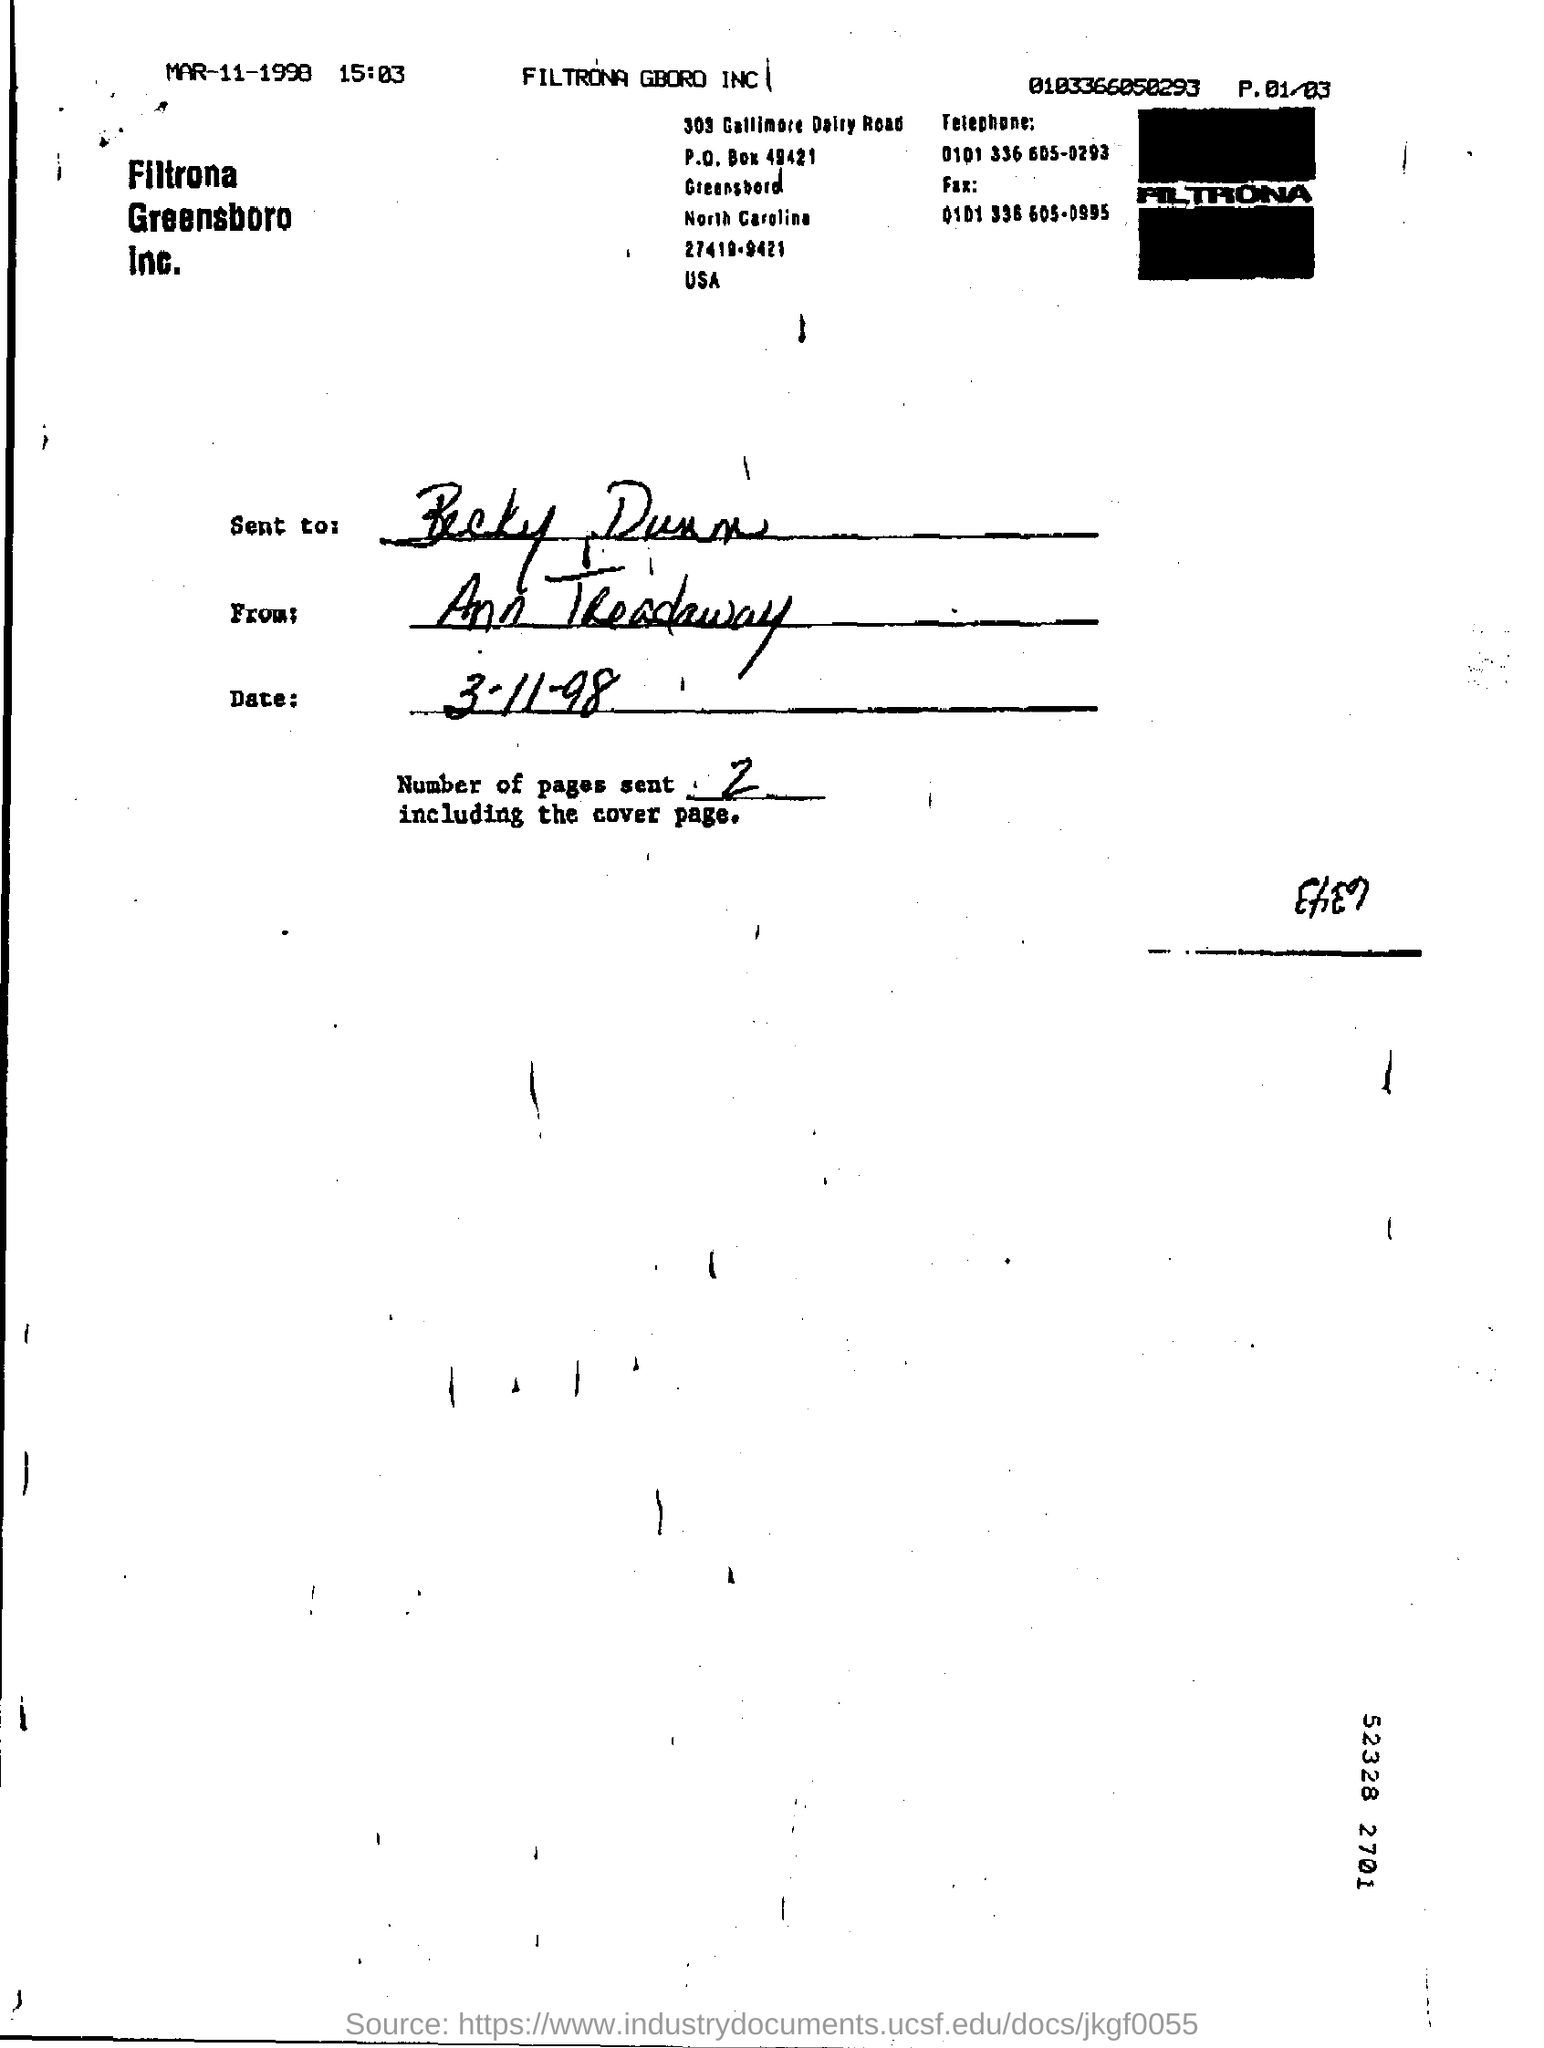Highlight a few significant elements in this photo. The document has been sent by Ann Treadaway. The date mentioned in the Date column is 3-11-98. The document was sent to Becky Dunn. 